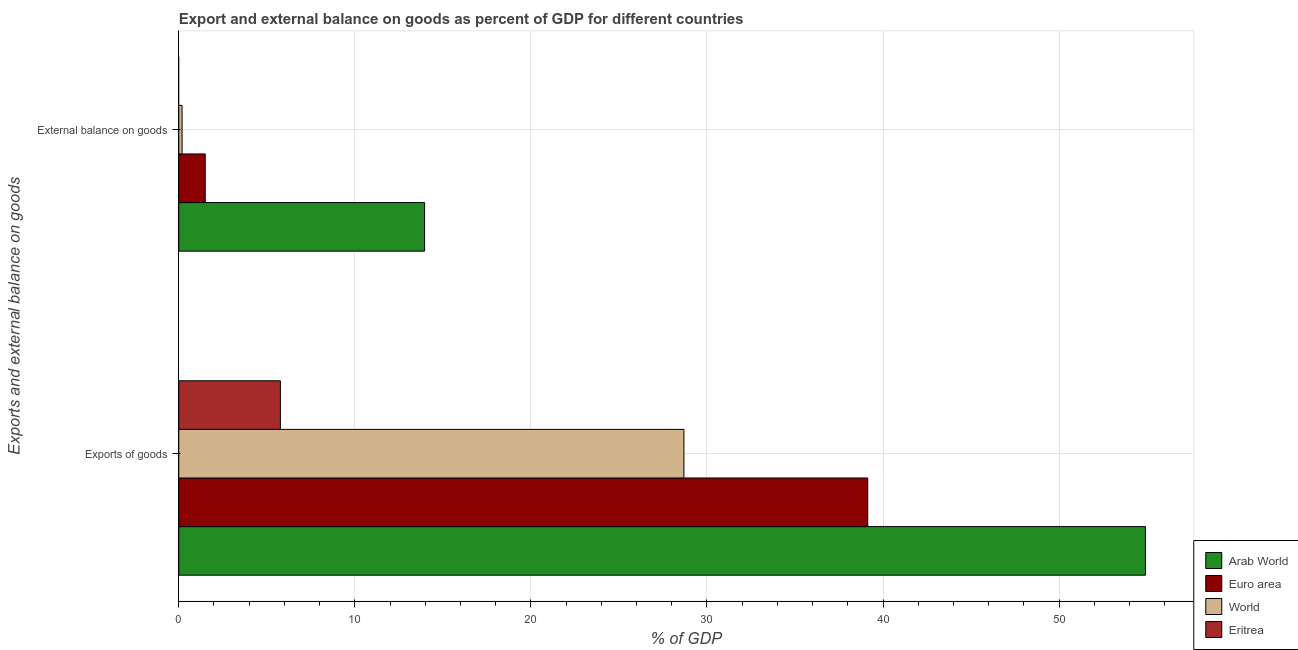How many different coloured bars are there?
Offer a terse response. 4. How many groups of bars are there?
Your answer should be compact. 2. Are the number of bars on each tick of the Y-axis equal?
Keep it short and to the point. No. How many bars are there on the 2nd tick from the top?
Ensure brevity in your answer.  4. How many bars are there on the 2nd tick from the bottom?
Your answer should be very brief. 3. What is the label of the 1st group of bars from the top?
Provide a succinct answer. External balance on goods. What is the export of goods as percentage of gdp in Arab World?
Provide a succinct answer. 54.9. Across all countries, what is the maximum export of goods as percentage of gdp?
Offer a very short reply. 54.9. Across all countries, what is the minimum export of goods as percentage of gdp?
Your answer should be very brief. 5.77. In which country was the external balance on goods as percentage of gdp maximum?
Offer a terse response. Arab World. What is the total export of goods as percentage of gdp in the graph?
Your answer should be very brief. 128.5. What is the difference between the external balance on goods as percentage of gdp in Euro area and that in Arab World?
Make the answer very short. -12.46. What is the difference between the external balance on goods as percentage of gdp in Arab World and the export of goods as percentage of gdp in World?
Your response must be concise. -14.73. What is the average external balance on goods as percentage of gdp per country?
Your answer should be very brief. 3.91. What is the difference between the export of goods as percentage of gdp and external balance on goods as percentage of gdp in Euro area?
Provide a short and direct response. 37.63. What is the ratio of the export of goods as percentage of gdp in Eritrea to that in World?
Your answer should be very brief. 0.2. How many bars are there?
Your answer should be very brief. 7. How many countries are there in the graph?
Keep it short and to the point. 4. Are the values on the major ticks of X-axis written in scientific E-notation?
Your answer should be compact. No. What is the title of the graph?
Provide a short and direct response. Export and external balance on goods as percent of GDP for different countries. Does "Turkmenistan" appear as one of the legend labels in the graph?
Provide a short and direct response. No. What is the label or title of the X-axis?
Your answer should be very brief. % of GDP. What is the label or title of the Y-axis?
Offer a very short reply. Exports and external balance on goods. What is the % of GDP in Arab World in Exports of goods?
Your response must be concise. 54.9. What is the % of GDP of Euro area in Exports of goods?
Provide a short and direct response. 39.13. What is the % of GDP in World in Exports of goods?
Offer a very short reply. 28.69. What is the % of GDP in Eritrea in Exports of goods?
Provide a short and direct response. 5.77. What is the % of GDP in Arab World in External balance on goods?
Your answer should be very brief. 13.96. What is the % of GDP of Euro area in External balance on goods?
Your answer should be compact. 1.5. What is the % of GDP in World in External balance on goods?
Offer a very short reply. 0.19. What is the % of GDP of Eritrea in External balance on goods?
Your answer should be very brief. 0. Across all Exports and external balance on goods, what is the maximum % of GDP in Arab World?
Give a very brief answer. 54.9. Across all Exports and external balance on goods, what is the maximum % of GDP of Euro area?
Give a very brief answer. 39.13. Across all Exports and external balance on goods, what is the maximum % of GDP in World?
Make the answer very short. 28.69. Across all Exports and external balance on goods, what is the maximum % of GDP in Eritrea?
Ensure brevity in your answer.  5.77. Across all Exports and external balance on goods, what is the minimum % of GDP in Arab World?
Your response must be concise. 13.96. Across all Exports and external balance on goods, what is the minimum % of GDP in Euro area?
Offer a terse response. 1.5. Across all Exports and external balance on goods, what is the minimum % of GDP of World?
Provide a succinct answer. 0.19. Across all Exports and external balance on goods, what is the minimum % of GDP in Eritrea?
Offer a very short reply. 0. What is the total % of GDP in Arab World in the graph?
Provide a short and direct response. 68.87. What is the total % of GDP of Euro area in the graph?
Give a very brief answer. 40.64. What is the total % of GDP of World in the graph?
Keep it short and to the point. 28.88. What is the total % of GDP of Eritrea in the graph?
Your response must be concise. 5.77. What is the difference between the % of GDP in Arab World in Exports of goods and that in External balance on goods?
Ensure brevity in your answer.  40.94. What is the difference between the % of GDP in Euro area in Exports of goods and that in External balance on goods?
Provide a succinct answer. 37.63. What is the difference between the % of GDP in World in Exports of goods and that in External balance on goods?
Your response must be concise. 28.5. What is the difference between the % of GDP of Arab World in Exports of goods and the % of GDP of Euro area in External balance on goods?
Offer a very short reply. 53.4. What is the difference between the % of GDP of Arab World in Exports of goods and the % of GDP of World in External balance on goods?
Your answer should be very brief. 54.72. What is the difference between the % of GDP of Euro area in Exports of goods and the % of GDP of World in External balance on goods?
Offer a terse response. 38.95. What is the average % of GDP in Arab World per Exports and external balance on goods?
Your answer should be compact. 34.43. What is the average % of GDP of Euro area per Exports and external balance on goods?
Your response must be concise. 20.32. What is the average % of GDP in World per Exports and external balance on goods?
Keep it short and to the point. 14.44. What is the average % of GDP in Eritrea per Exports and external balance on goods?
Offer a terse response. 2.89. What is the difference between the % of GDP in Arab World and % of GDP in Euro area in Exports of goods?
Provide a succinct answer. 15.77. What is the difference between the % of GDP of Arab World and % of GDP of World in Exports of goods?
Your answer should be compact. 26.21. What is the difference between the % of GDP of Arab World and % of GDP of Eritrea in Exports of goods?
Keep it short and to the point. 49.13. What is the difference between the % of GDP in Euro area and % of GDP in World in Exports of goods?
Ensure brevity in your answer.  10.44. What is the difference between the % of GDP in Euro area and % of GDP in Eritrea in Exports of goods?
Keep it short and to the point. 33.36. What is the difference between the % of GDP of World and % of GDP of Eritrea in Exports of goods?
Your answer should be very brief. 22.92. What is the difference between the % of GDP in Arab World and % of GDP in Euro area in External balance on goods?
Your answer should be very brief. 12.46. What is the difference between the % of GDP of Arab World and % of GDP of World in External balance on goods?
Your response must be concise. 13.78. What is the difference between the % of GDP of Euro area and % of GDP of World in External balance on goods?
Make the answer very short. 1.32. What is the ratio of the % of GDP of Arab World in Exports of goods to that in External balance on goods?
Offer a terse response. 3.93. What is the ratio of the % of GDP of Euro area in Exports of goods to that in External balance on goods?
Ensure brevity in your answer.  26.04. What is the ratio of the % of GDP of World in Exports of goods to that in External balance on goods?
Your answer should be compact. 153.24. What is the difference between the highest and the second highest % of GDP in Arab World?
Offer a terse response. 40.94. What is the difference between the highest and the second highest % of GDP of Euro area?
Make the answer very short. 37.63. What is the difference between the highest and the second highest % of GDP in World?
Your answer should be very brief. 28.5. What is the difference between the highest and the lowest % of GDP in Arab World?
Offer a very short reply. 40.94. What is the difference between the highest and the lowest % of GDP in Euro area?
Make the answer very short. 37.63. What is the difference between the highest and the lowest % of GDP in World?
Offer a very short reply. 28.5. What is the difference between the highest and the lowest % of GDP of Eritrea?
Provide a short and direct response. 5.77. 